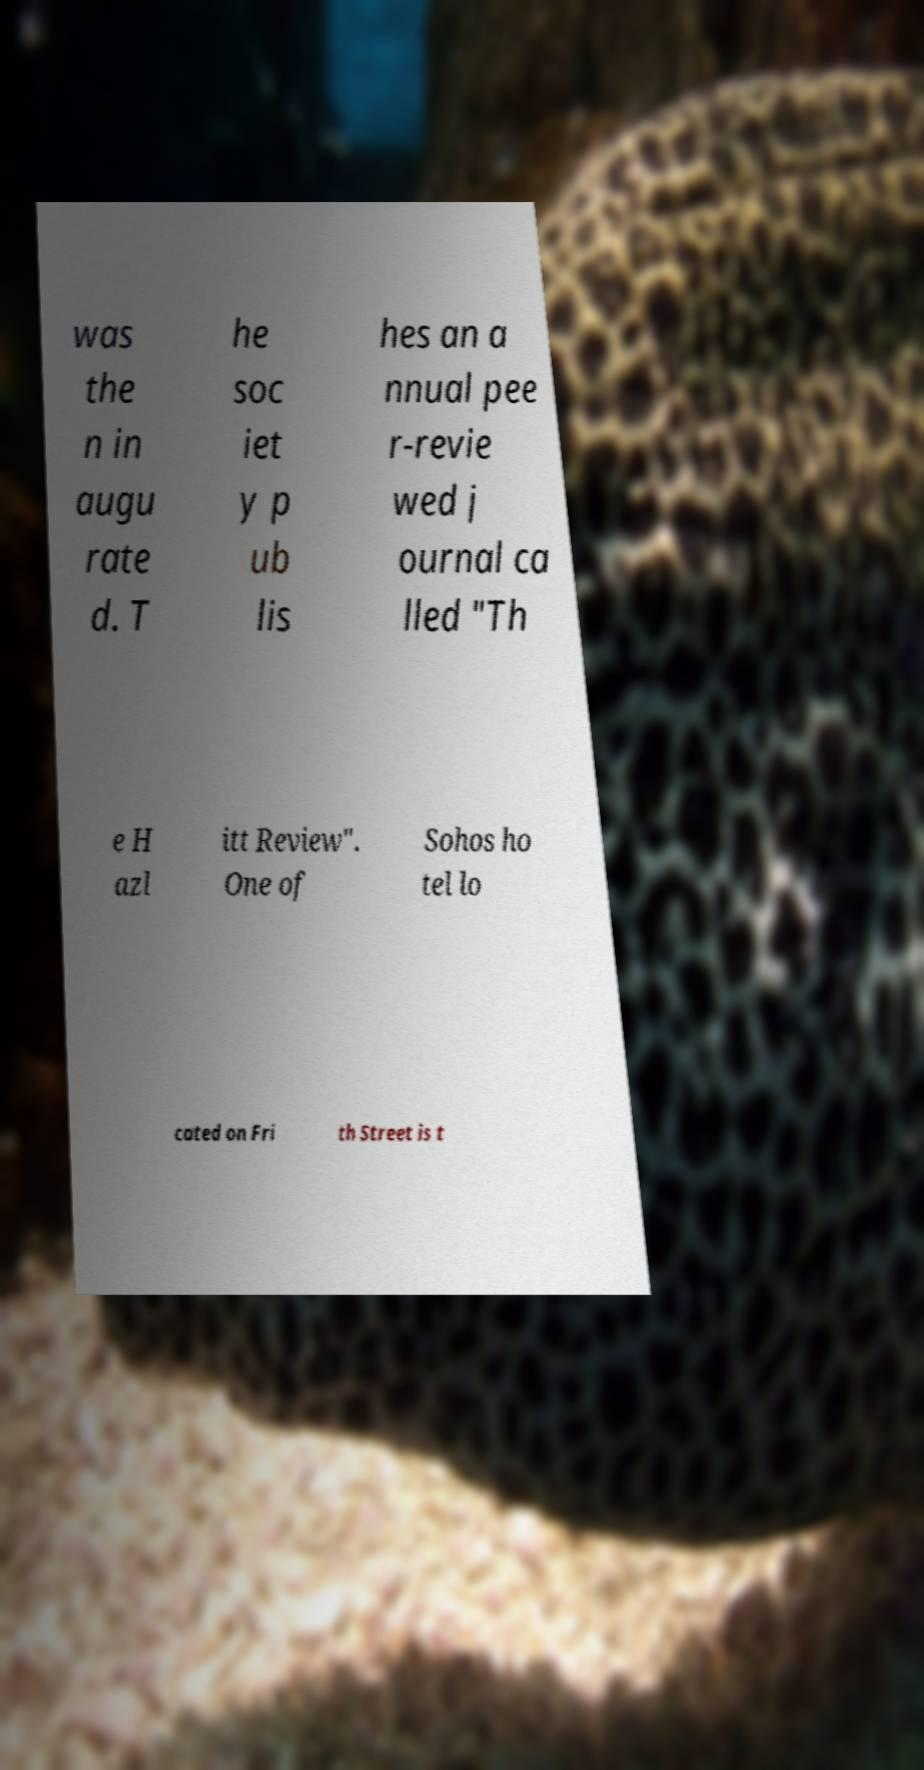I need the written content from this picture converted into text. Can you do that? was the n in augu rate d. T he soc iet y p ub lis hes an a nnual pee r-revie wed j ournal ca lled "Th e H azl itt Review". One of Sohos ho tel lo cated on Fri th Street is t 